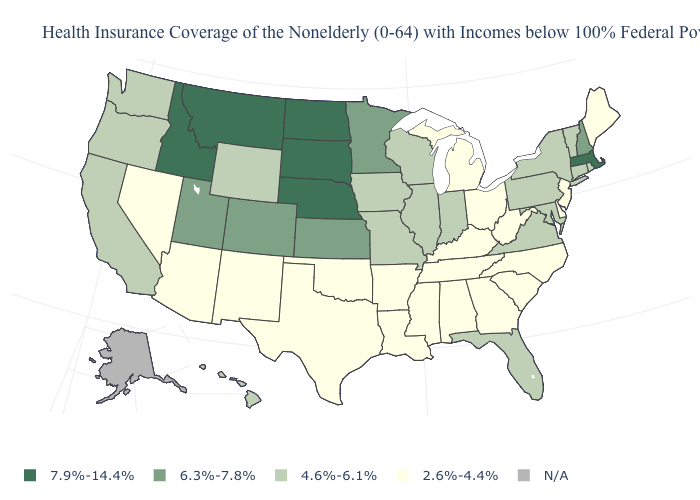Name the states that have a value in the range 4.6%-6.1%?
Answer briefly. California, Connecticut, Florida, Hawaii, Illinois, Indiana, Iowa, Maryland, Missouri, New York, Oregon, Pennsylvania, Rhode Island, Vermont, Virginia, Washington, Wisconsin, Wyoming. What is the value of Hawaii?
Keep it brief. 4.6%-6.1%. What is the value of West Virginia?
Quick response, please. 2.6%-4.4%. What is the value of Louisiana?
Quick response, please. 2.6%-4.4%. Does Massachusetts have the lowest value in the Northeast?
Write a very short answer. No. Does California have the lowest value in the USA?
Write a very short answer. No. Name the states that have a value in the range 6.3%-7.8%?
Quick response, please. Colorado, Kansas, Minnesota, New Hampshire, Utah. What is the value of Nebraska?
Answer briefly. 7.9%-14.4%. Name the states that have a value in the range 4.6%-6.1%?
Give a very brief answer. California, Connecticut, Florida, Hawaii, Illinois, Indiana, Iowa, Maryland, Missouri, New York, Oregon, Pennsylvania, Rhode Island, Vermont, Virginia, Washington, Wisconsin, Wyoming. What is the value of California?
Short answer required. 4.6%-6.1%. Among the states that border New Hampshire , does Massachusetts have the highest value?
Concise answer only. Yes. Among the states that border Illinois , which have the highest value?
Give a very brief answer. Indiana, Iowa, Missouri, Wisconsin. Which states have the highest value in the USA?
Keep it brief. Idaho, Massachusetts, Montana, Nebraska, North Dakota, South Dakota. 